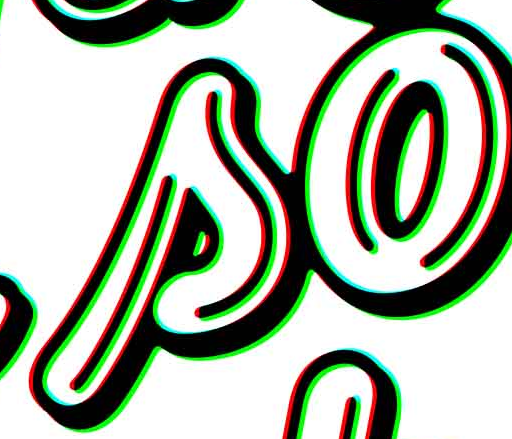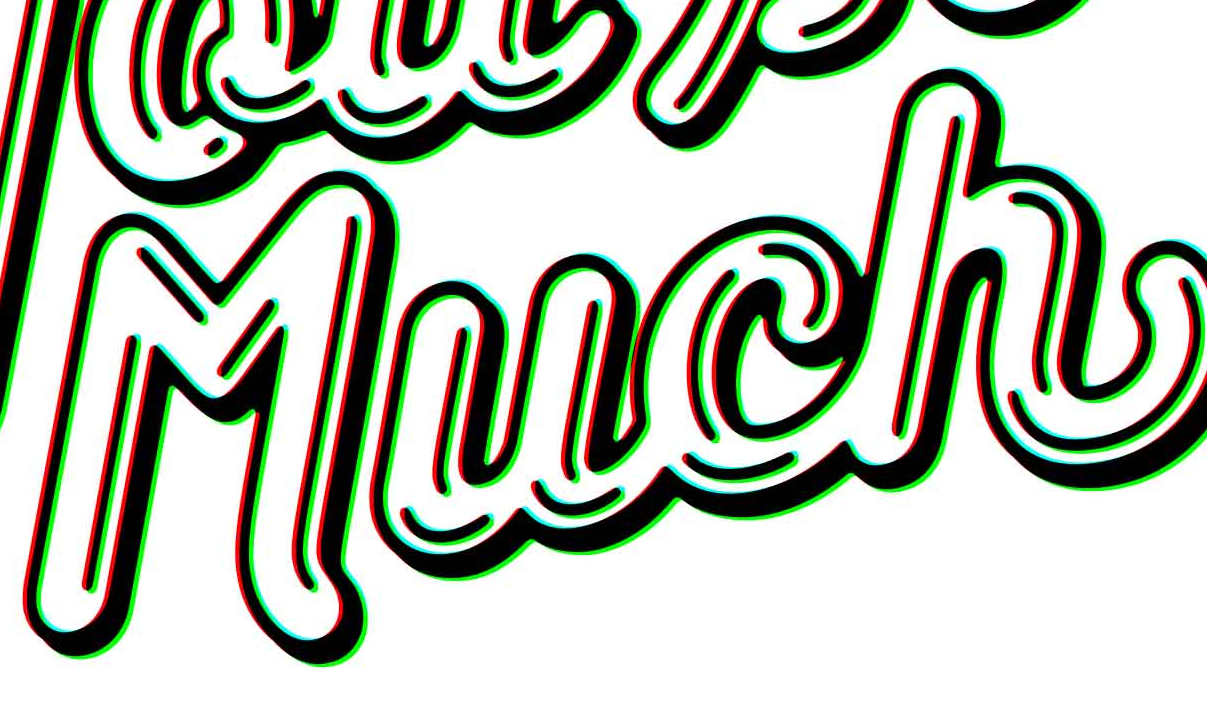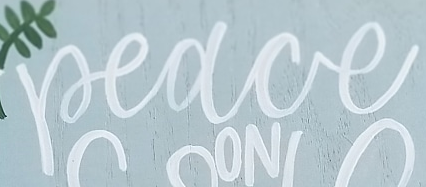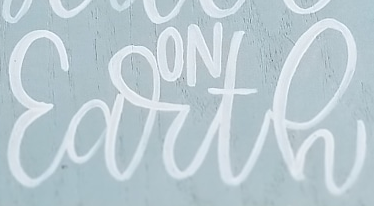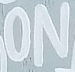What text is displayed in these images sequentially, separated by a semicolon? so; Much; Peace; Earth; ON 